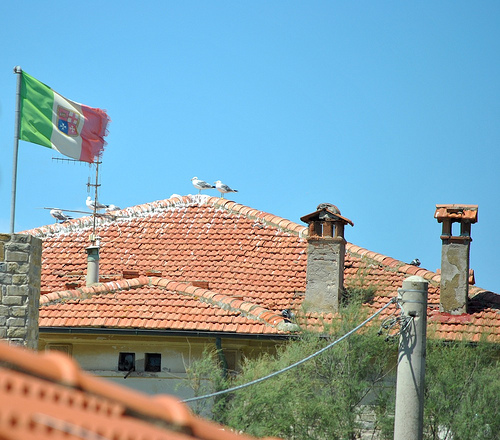<image>
Can you confirm if the roof is under the sky? Yes. The roof is positioned underneath the sky, with the sky above it in the vertical space. 